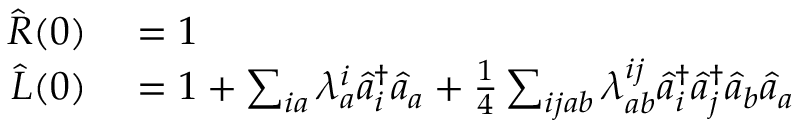Convert formula to latex. <formula><loc_0><loc_0><loc_500><loc_500>\begin{array} { r l } { \hat { R } ( 0 ) } & = 1 } \\ { \hat { L } ( 0 ) } & = 1 + \sum _ { i a } \lambda _ { a } ^ { i } \hat { a } _ { i } ^ { \dagger } \hat { a } _ { a } + \frac { 1 } { 4 } \sum _ { i j a b } \lambda _ { a b } ^ { i j } \hat { a } _ { i } ^ { \dagger } \hat { a } _ { j } ^ { \dagger } \hat { a } _ { b } \hat { a } _ { a } } \end{array}</formula> 